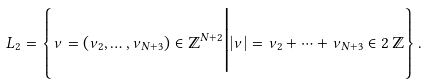Convert formula to latex. <formula><loc_0><loc_0><loc_500><loc_500>L _ { 2 } = \left \{ \nu = ( \nu _ { 2 } , \dots , \nu _ { N + 3 } ) \in \mathbb { Z } ^ { N + 2 } \Big | | \nu | = \nu _ { 2 } + \cdots + \nu _ { N + 3 } \in 2 \, \mathbb { Z } \right \} .</formula> 